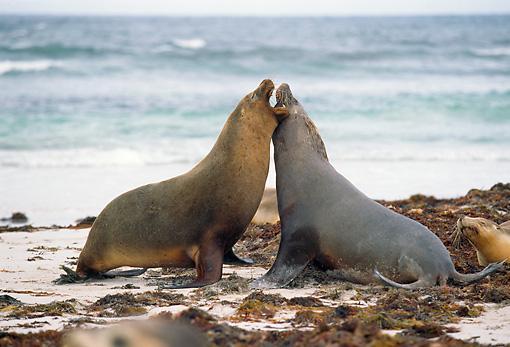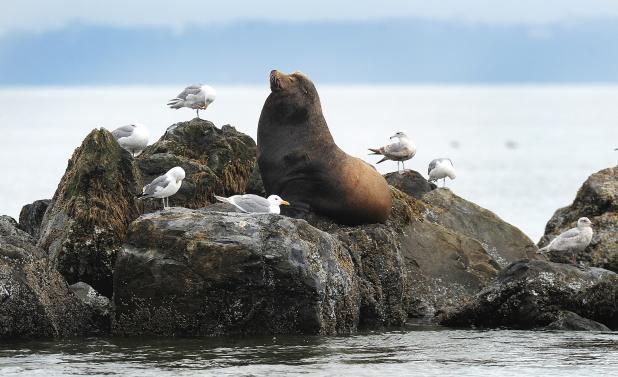The first image is the image on the left, the second image is the image on the right. Evaluate the accuracy of this statement regarding the images: "The left image only has two seals.". Is it true? Answer yes or no. Yes. The first image is the image on the left, the second image is the image on the right. Examine the images to the left and right. Is the description "An image shows exactly two seals in direct contact, posed face to face." accurate? Answer yes or no. Yes. 